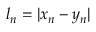Convert formula to latex. <formula><loc_0><loc_0><loc_500><loc_500>\begin{array} { r } { l _ { n } = | x _ { n } - y _ { n } | } \end{array}</formula> 